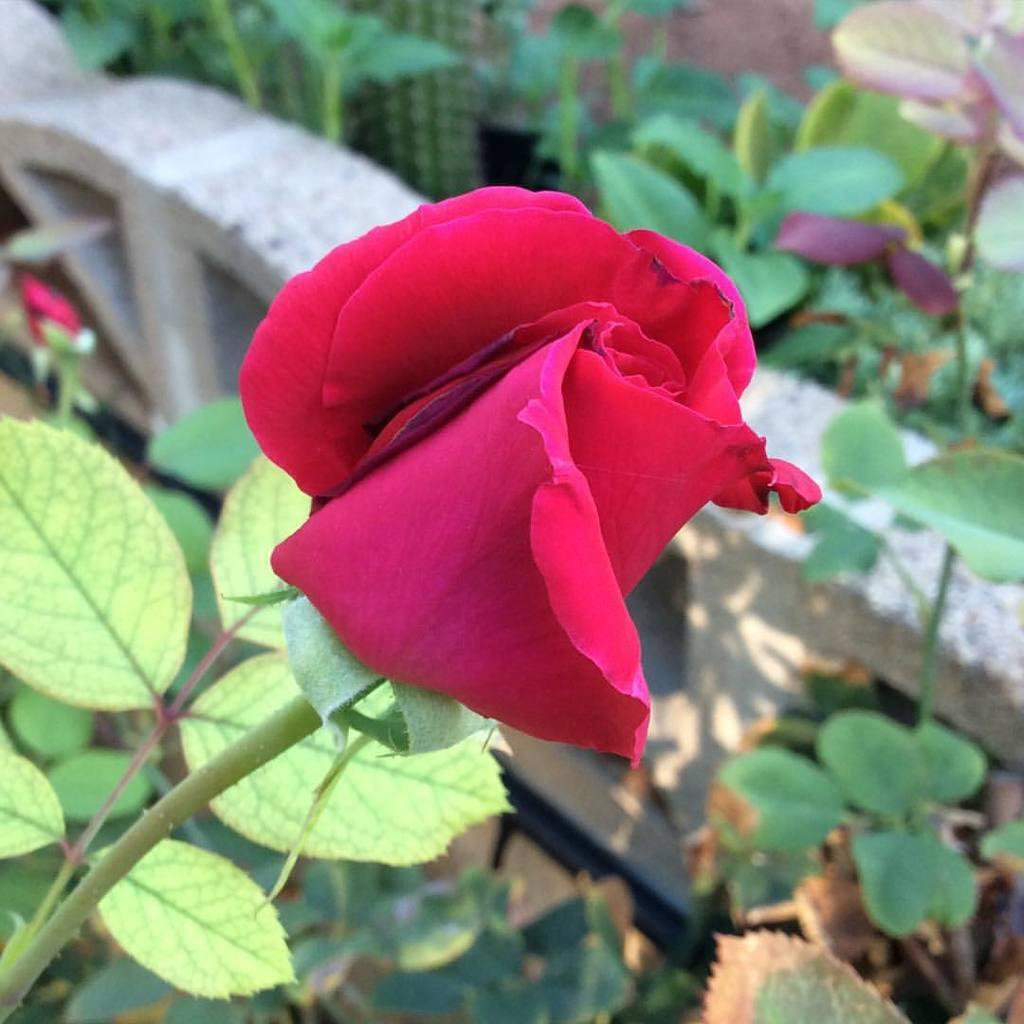What type of plant is in the image? There is a plant in the image with a rose flower. What color is the rose flower? The rose flower is red in color. What is located beside the plant? There is a railing wall beside the plant. What can be seen inside the railing wall along a path? There are plants inside the railing wall along a path. What type of crime is being committed in the image? There is no crime being committed in the image; it features a plant with a red rose flower and a railing wall. Can you describe the yak grazing in the image? There is no yak present in the image; it features a plant with a red rose flower and a railing wall. 